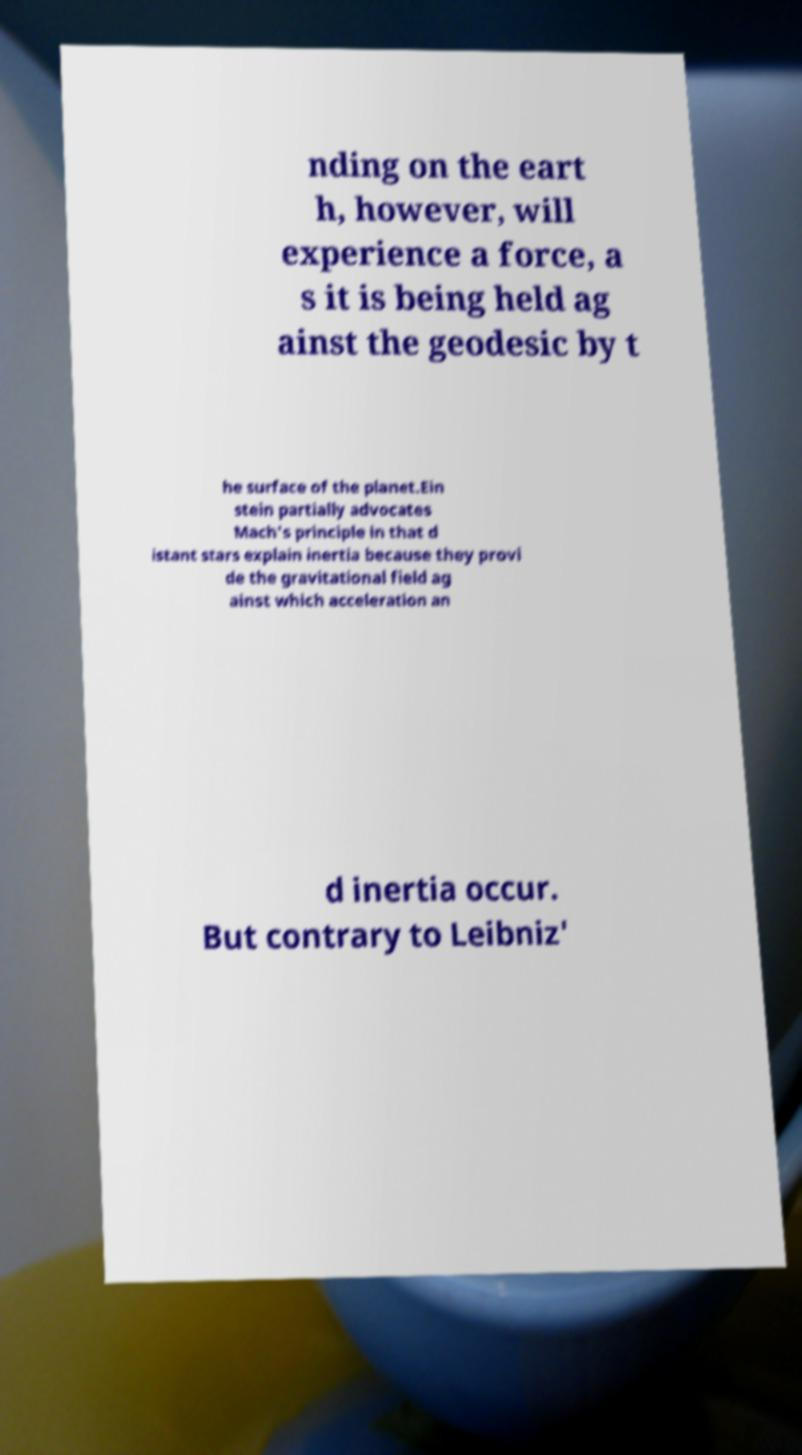What messages or text are displayed in this image? I need them in a readable, typed format. nding on the eart h, however, will experience a force, a s it is being held ag ainst the geodesic by t he surface of the planet.Ein stein partially advocates Mach's principle in that d istant stars explain inertia because they provi de the gravitational field ag ainst which acceleration an d inertia occur. But contrary to Leibniz' 